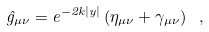<formula> <loc_0><loc_0><loc_500><loc_500>\hat { g } _ { \mu \nu } = e ^ { - 2 k | y | } \left ( \eta _ { \mu \nu } + \gamma _ { \mu \nu } \right ) \ ,</formula> 